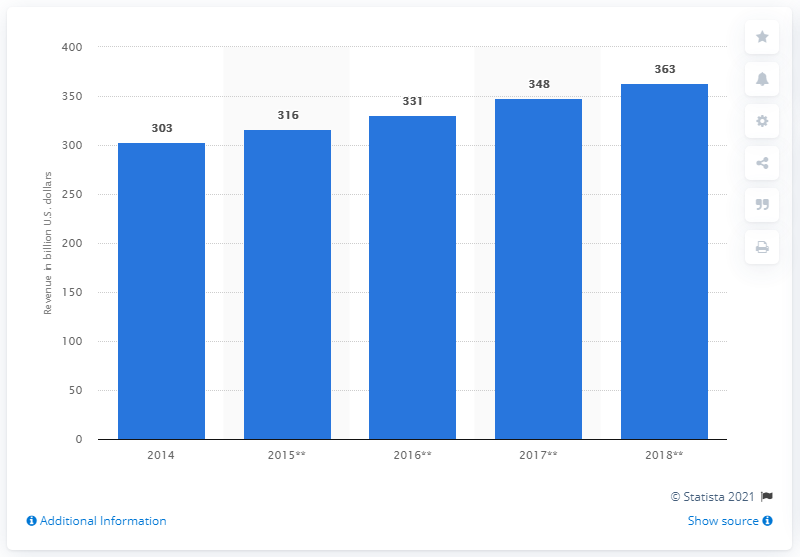Identify some key points in this picture. The total available market for electronics components in the U.S. in 2014 was approximately 303 billion U.S. dollars. 